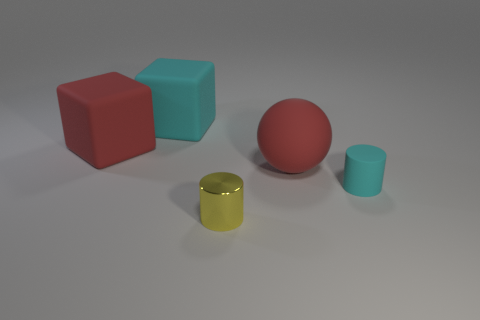Add 1 rubber cubes. How many objects exist? 6 Subtract 2 cylinders. How many cylinders are left? 0 Subtract all blocks. How many objects are left? 3 Subtract all yellow objects. Subtract all small yellow objects. How many objects are left? 3 Add 5 big cyan matte cubes. How many big cyan matte cubes are left? 6 Add 2 tiny red rubber things. How many tiny red rubber things exist? 2 Subtract 1 cyan blocks. How many objects are left? 4 Subtract all blue balls. Subtract all brown cylinders. How many balls are left? 1 